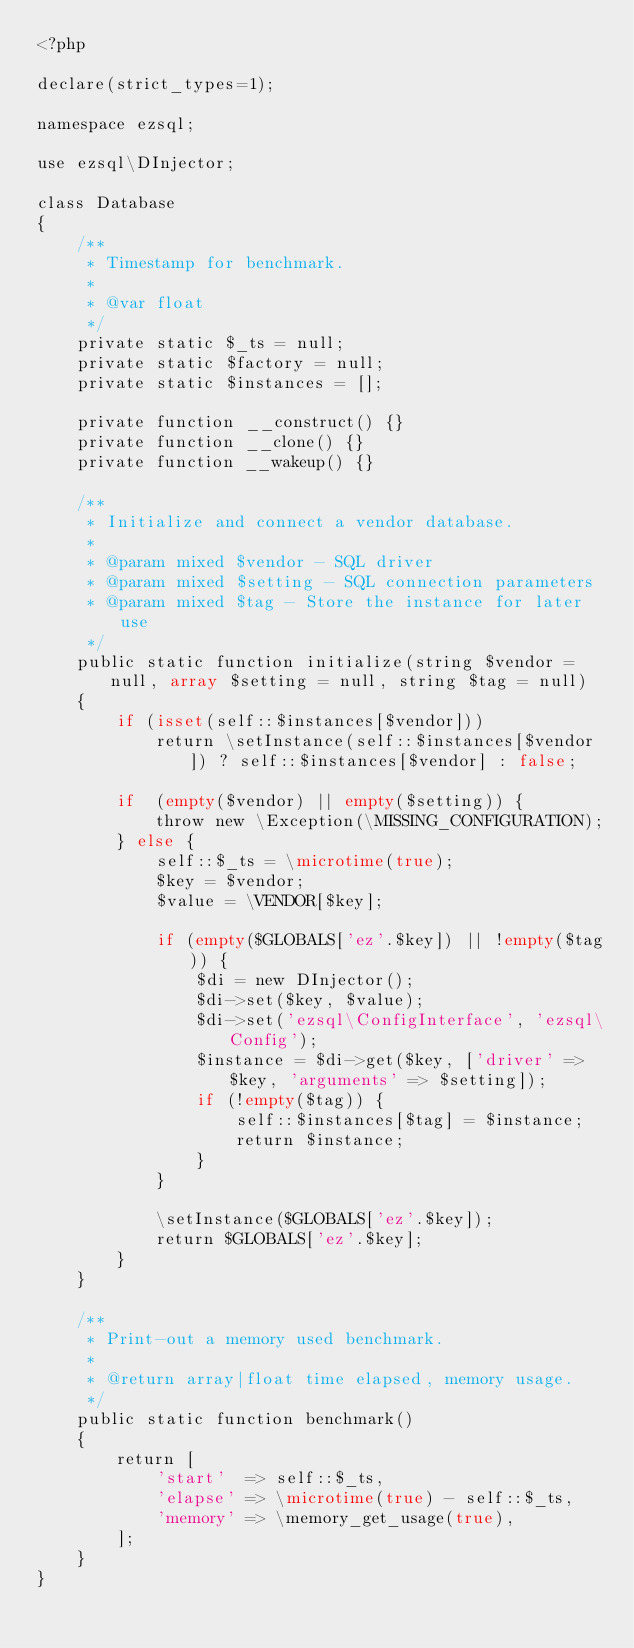<code> <loc_0><loc_0><loc_500><loc_500><_PHP_><?php 

declare(strict_types=1);

namespace ezsql;

use ezsql\DInjector;

class Database
{
    /**
     * Timestamp for benchmark.
     *
     * @var float
     */
    private static $_ts = null;
    private static $factory = null;
    private static $instances = [];

    private function __construct() {}
    private function __clone() {}
    private function __wakeup() {}

    /**
     * Initialize and connect a vendor database.
     * 
     * @param mixed $vendor - SQL driver
     * @param mixed $setting - SQL connection parameters
     * @param mixed $tag - Store the instance for later use
     */
    public static function initialize(string $vendor = null, array $setting = null, string $tag = null)
    {
        if (isset(self::$instances[$vendor]))
            return \setInstance(self::$instances[$vendor]) ? self::$instances[$vendor] : false;
        
        if  (empty($vendor) || empty($setting)) {
            throw new \Exception(\MISSING_CONFIGURATION);
        } else {
            self::$_ts = \microtime(true);
            $key = $vendor;
            $value = \VENDOR[$key];

            if (empty($GLOBALS['ez'.$key]) || !empty($tag)) {
                $di = new DInjector();
                $di->set($key, $value);                
                $di->set('ezsql\ConfigInterface', 'ezsql\Config');
                $instance = $di->get($key, ['driver' => $key, 'arguments' => $setting]);
                if (!empty($tag)) {
                    self::$instances[$tag] = $instance;
                    return $instance;
                }
            }

            \setInstance($GLOBALS['ez'.$key]);
            return $GLOBALS['ez'.$key];
        }
    }

    /**
     * Print-out a memory used benchmark.
     *
     * @return array|float time elapsed, memory usage.
     */
    public static function benchmark()
    {
        return [
            'start'  => self::$_ts,
            'elapse' => \microtime(true) - self::$_ts,
            'memory' => \memory_get_usage(true),
        ];
    }
}</code> 